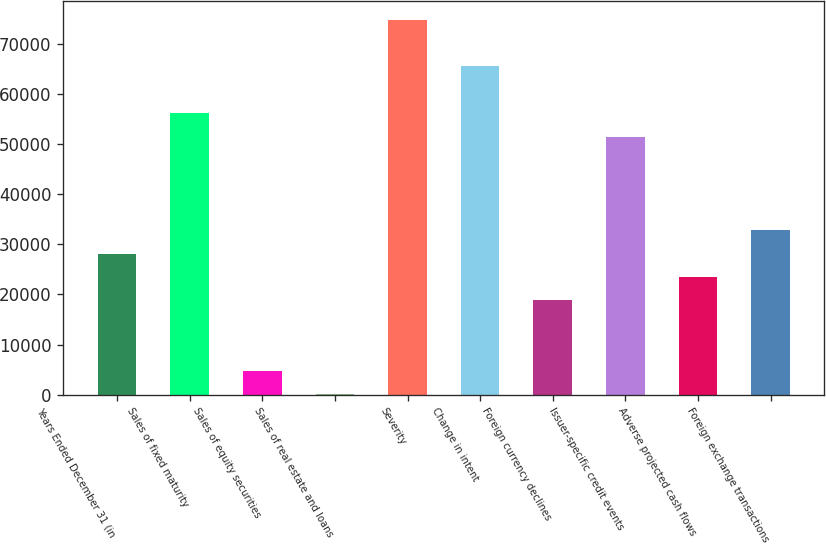<chart> <loc_0><loc_0><loc_500><loc_500><bar_chart><fcel>Years Ended December 31 (in<fcel>Sales of fixed maturity<fcel>Sales of equity securities<fcel>Sales of real estate and loans<fcel>Severity<fcel>Change in intent<fcel>Foreign currency declines<fcel>Issuer-specific credit events<fcel>Adverse projected cash flows<fcel>Foreign exchange transactions<nl><fcel>28130.8<fcel>56125.6<fcel>4801.8<fcel>136<fcel>74788.8<fcel>65457.2<fcel>18799.2<fcel>51459.8<fcel>23465<fcel>32796.6<nl></chart> 